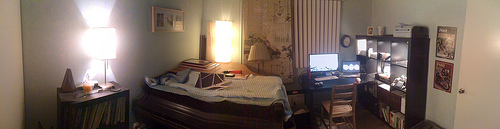Please provide the bounding box coordinate of the region this sentence describes: A white house wall. [0.83, 0.38, 0.95, 0.44] Please provide a short description for this region: [0.91, 0.53, 0.93, 0.57]. Knob on the white door. Please provide the bounding box coordinate of the region this sentence describes: A sharp light from the window. [0.14, 0.37, 0.26, 0.54] Please provide the bounding box coordinate of the region this sentence describes: a monitor on top of a desk. [0.61, 0.47, 0.68, 0.52] Please provide a short description for this region: [0.63, 0.53, 0.73, 0.62]. Chair under computer desk. Please provide the bounding box coordinate of the region this sentence describes: the back chair legs. [0.65, 0.59, 0.73, 0.62] Please provide a short description for this region: [0.04, 0.43, 0.12, 0.52]. A white house wall. Please provide a short description for this region: [0.16, 0.37, 0.24, 0.53]. Lights bright on wall. Please provide a short description for this region: [0.64, 0.53, 0.72, 0.62]. A chair in front of the desk. 